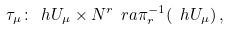<formula> <loc_0><loc_0><loc_500><loc_500>\tau _ { \mu } \colon \ h U _ { \mu } \times N ^ { r } \ r a \pi _ { r } ^ { - 1 } ( \ h U _ { \mu } ) \, ,</formula> 